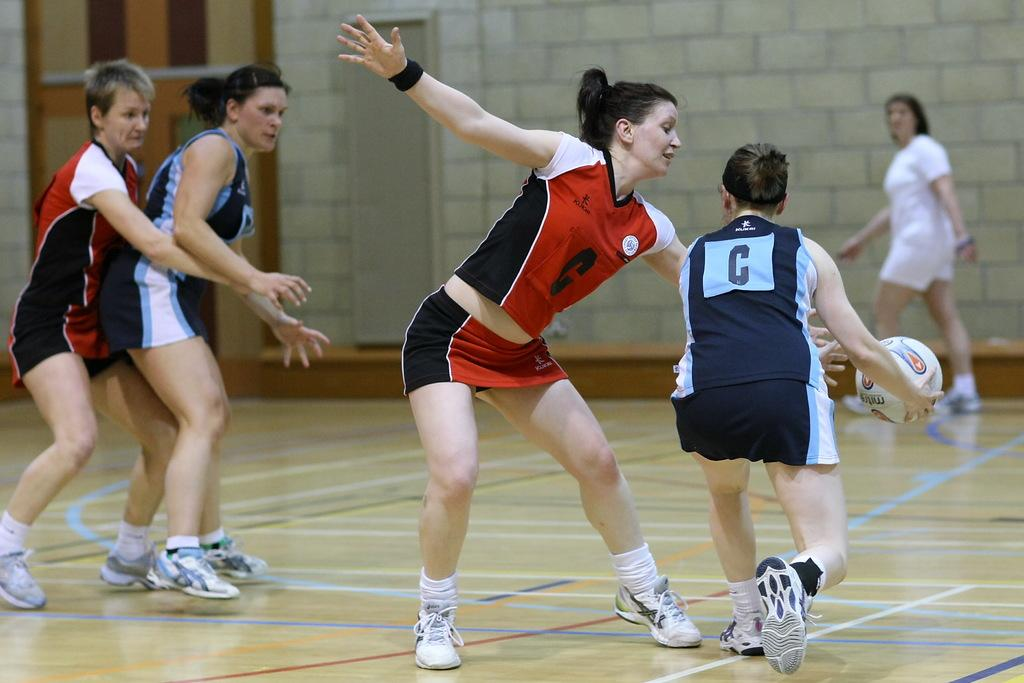<image>
Create a compact narrative representing the image presented. A woman players a sport with the letter C on the back of her jersey. 